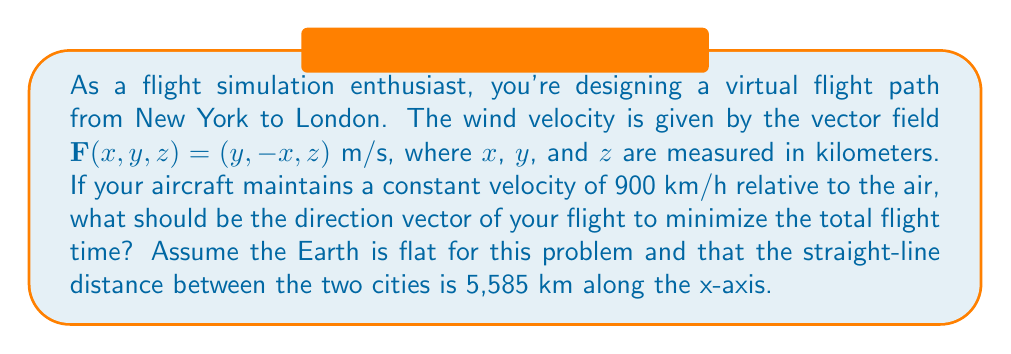What is the answer to this math problem? To solve this problem, we need to use vector calculus to determine the optimal flight path. Let's approach this step-by-step:

1) First, we need to understand that the optimal path will be the one where the aircraft's velocity relative to the ground is maximized in the direction of the destination.

2) Let's denote the aircraft's velocity vector relative to the air as $\mathbf{v}$. We know that $|\mathbf{v}| = 900$ km/h.

3) The aircraft's velocity relative to the ground, $\mathbf{V}$, is the sum of $\mathbf{v}$ and the wind velocity $\mathbf{F}$:

   $\mathbf{V} = \mathbf{v} + \mathbf{F}$

4) We want to maximize the x-component of $\mathbf{V}$, as the destination is along the x-axis.

5) Let's express $\mathbf{v}$ in terms of its components: $\mathbf{v} = (v_x, v_y, v_z)$

6) Now, $\mathbf{V} = (v_x + y, v_y - x, v_z + z)$

7) We want to maximize $V_x = v_x + y$ subject to the constraint $v_x^2 + v_y^2 + v_z^2 = 900^2$

8) This is a constrained optimization problem. We can solve it using the method of Lagrange multipliers, but there's a simpler intuitive solution:

9) To maximize $V_x$, we should choose $v_y = -x$ and $v_z = -z$. This way, the aircraft's velocity cancels out the y and z components of the wind, ensuring all of the aircraft's speed is used in the x-direction.

10) Given $v_y = -x$ and $v_z = -z$, we can find $v_x$:

    $v_x^2 + (-x)^2 + (-z)^2 = 900^2$
    $v_x = \sqrt{900^2 - x^2 - z^2}$

11) Therefore, the optimal direction vector at any point $(x,y,z)$ is:

    $\mathbf{v} = (\sqrt{900^2 - x^2 - z^2}, -x, -z)$

This vector will always point in the direction that maximizes the aircraft's velocity relative to the ground in the x-direction, taking into account the wind field.
Answer: The optimal direction vector for the flight at any point $(x,y,z)$ is:

$$\mathbf{v} = (\sqrt{900^2 - x^2 - z^2}, -x, -z)$$

where $x$, $y$, and $z$ are measured in kilometers. 